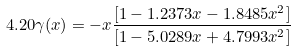<formula> <loc_0><loc_0><loc_500><loc_500>4 . 2 0 \gamma ( x ) = - x \frac { [ 1 - 1 . 2 3 7 3 x - 1 . 8 4 8 5 x ^ { 2 } ] } { [ 1 - 5 . 0 2 8 9 x + 4 . 7 9 9 3 x ^ { 2 } ] }</formula> 